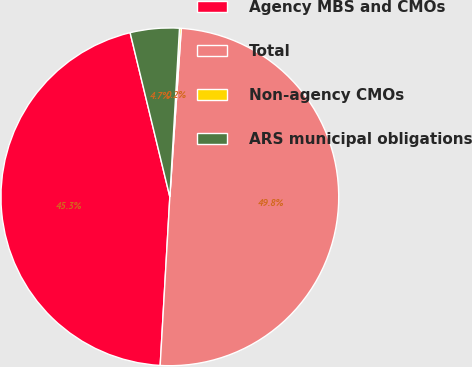Convert chart. <chart><loc_0><loc_0><loc_500><loc_500><pie_chart><fcel>Agency MBS and CMOs<fcel>Total<fcel>Non-agency CMOs<fcel>ARS municipal obligations<nl><fcel>45.31%<fcel>49.83%<fcel>0.17%<fcel>4.69%<nl></chart> 